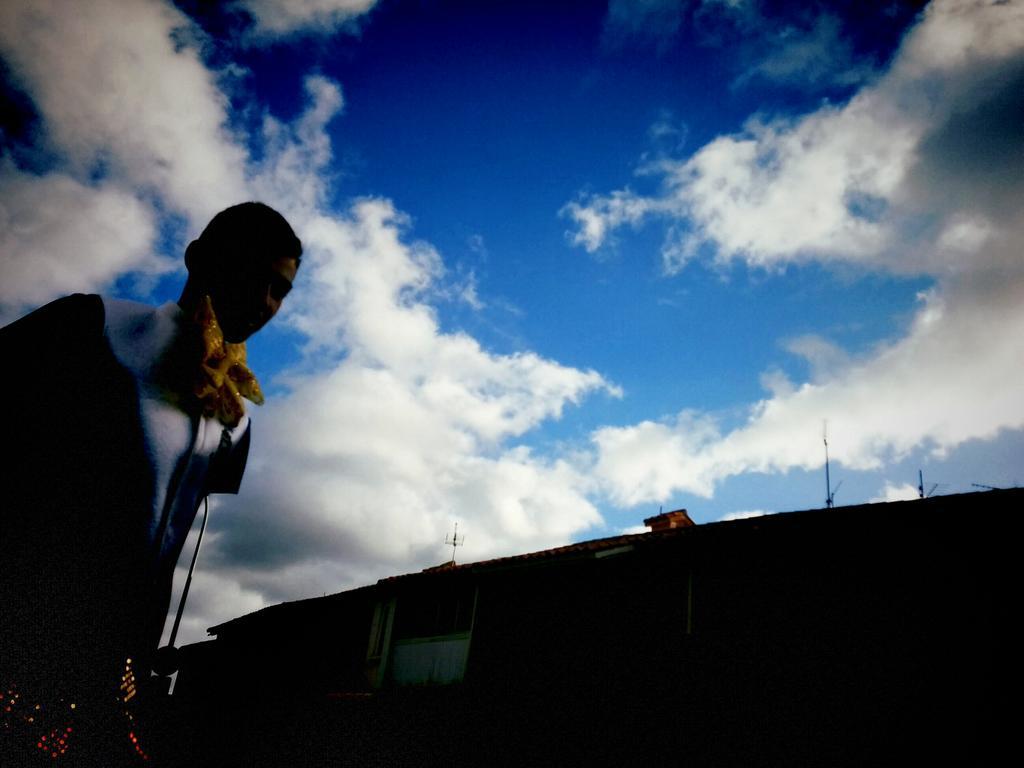Could you give a brief overview of what you see in this image? In this image there is one person standing on the left side of this image and there is a house on the bottom of this image and there is a cloudy sky on the top of this image. 